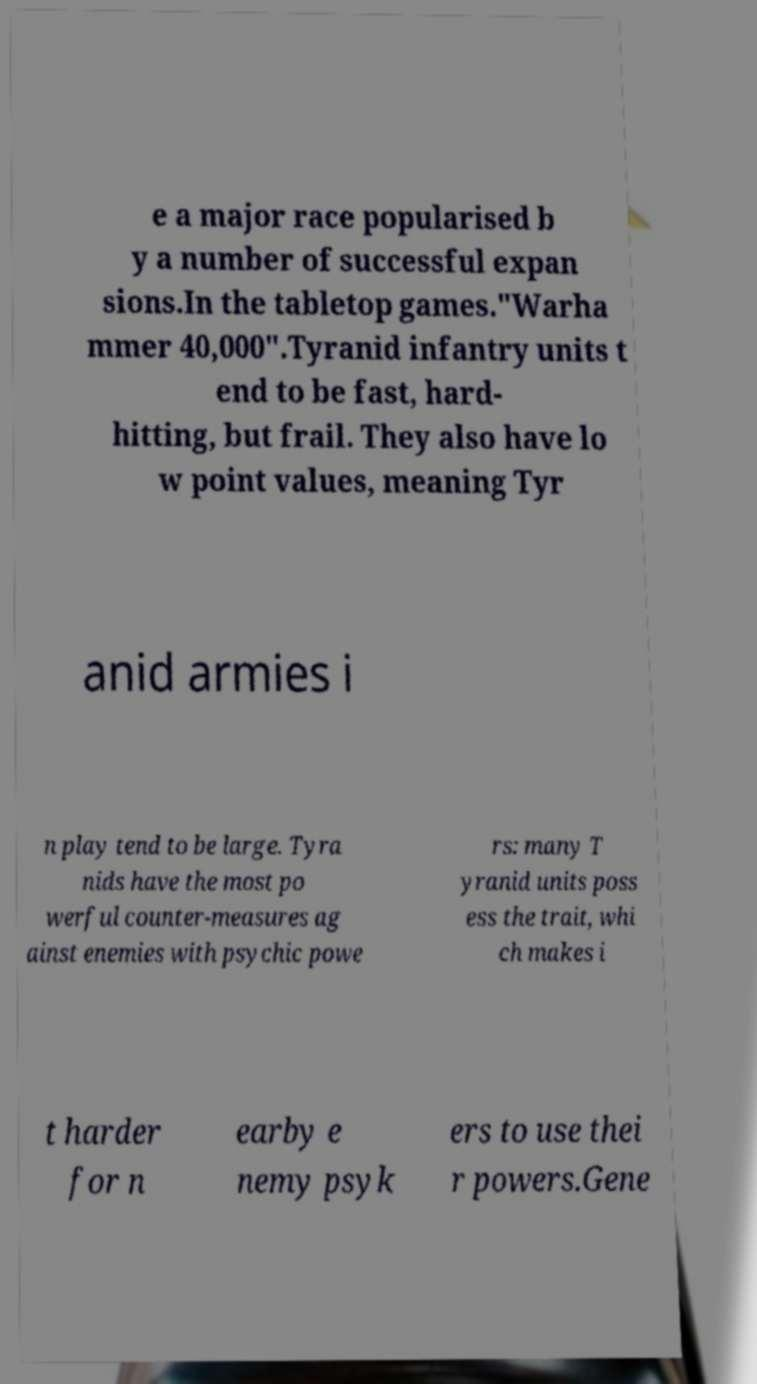I need the written content from this picture converted into text. Can you do that? e a major race popularised b y a number of successful expan sions.In the tabletop games."Warha mmer 40,000".Tyranid infantry units t end to be fast, hard- hitting, but frail. They also have lo w point values, meaning Tyr anid armies i n play tend to be large. Tyra nids have the most po werful counter-measures ag ainst enemies with psychic powe rs: many T yranid units poss ess the trait, whi ch makes i t harder for n earby e nemy psyk ers to use thei r powers.Gene 